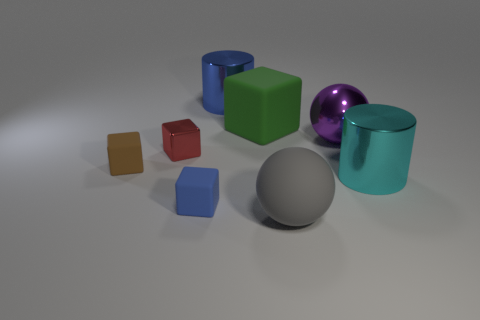Do the big shiny object that is in front of the big purple sphere and the big matte object that is on the left side of the large gray ball have the same shape?
Offer a very short reply. No. Does the gray object have the same size as the metallic cylinder in front of the small metal object?
Your answer should be very brief. Yes. What number of other things are made of the same material as the cyan cylinder?
Offer a terse response. 3. Is there anything else that is the same shape as the cyan shiny object?
Give a very brief answer. Yes. What is the color of the cylinder in front of the blue object behind the big rubber object that is behind the gray matte thing?
Keep it short and to the point. Cyan. There is a large object that is both in front of the tiny red shiny thing and behind the big gray rubber ball; what is its shape?
Provide a short and direct response. Cylinder. Is there anything else that is the same size as the gray thing?
Your response must be concise. Yes. The large rubber thing that is in front of the small rubber cube on the left side of the small blue block is what color?
Ensure brevity in your answer.  Gray. There is a small matte thing in front of the large cylinder that is in front of the matte block on the right side of the blue metallic cylinder; what is its shape?
Provide a short and direct response. Cube. There is a rubber object that is behind the big cyan cylinder and in front of the small metal cube; how big is it?
Give a very brief answer. Small. 